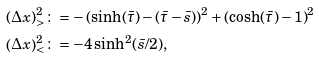Convert formula to latex. <formula><loc_0><loc_0><loc_500><loc_500>\left ( \Delta x \right ) ^ { 2 } _ { > } & \colon = - \left ( \sinh ( \bar { \tau } ) - ( \bar { \tau } - \bar { s } ) \right ) ^ { 2 } + \left ( \cosh ( \bar { \tau } ) - 1 \right ) ^ { 2 } \\ \left ( \Delta x \right ) ^ { 2 } _ { < } & \colon = - 4 \sinh ^ { 2 } ( \bar { s } / 2 ) ,</formula> 